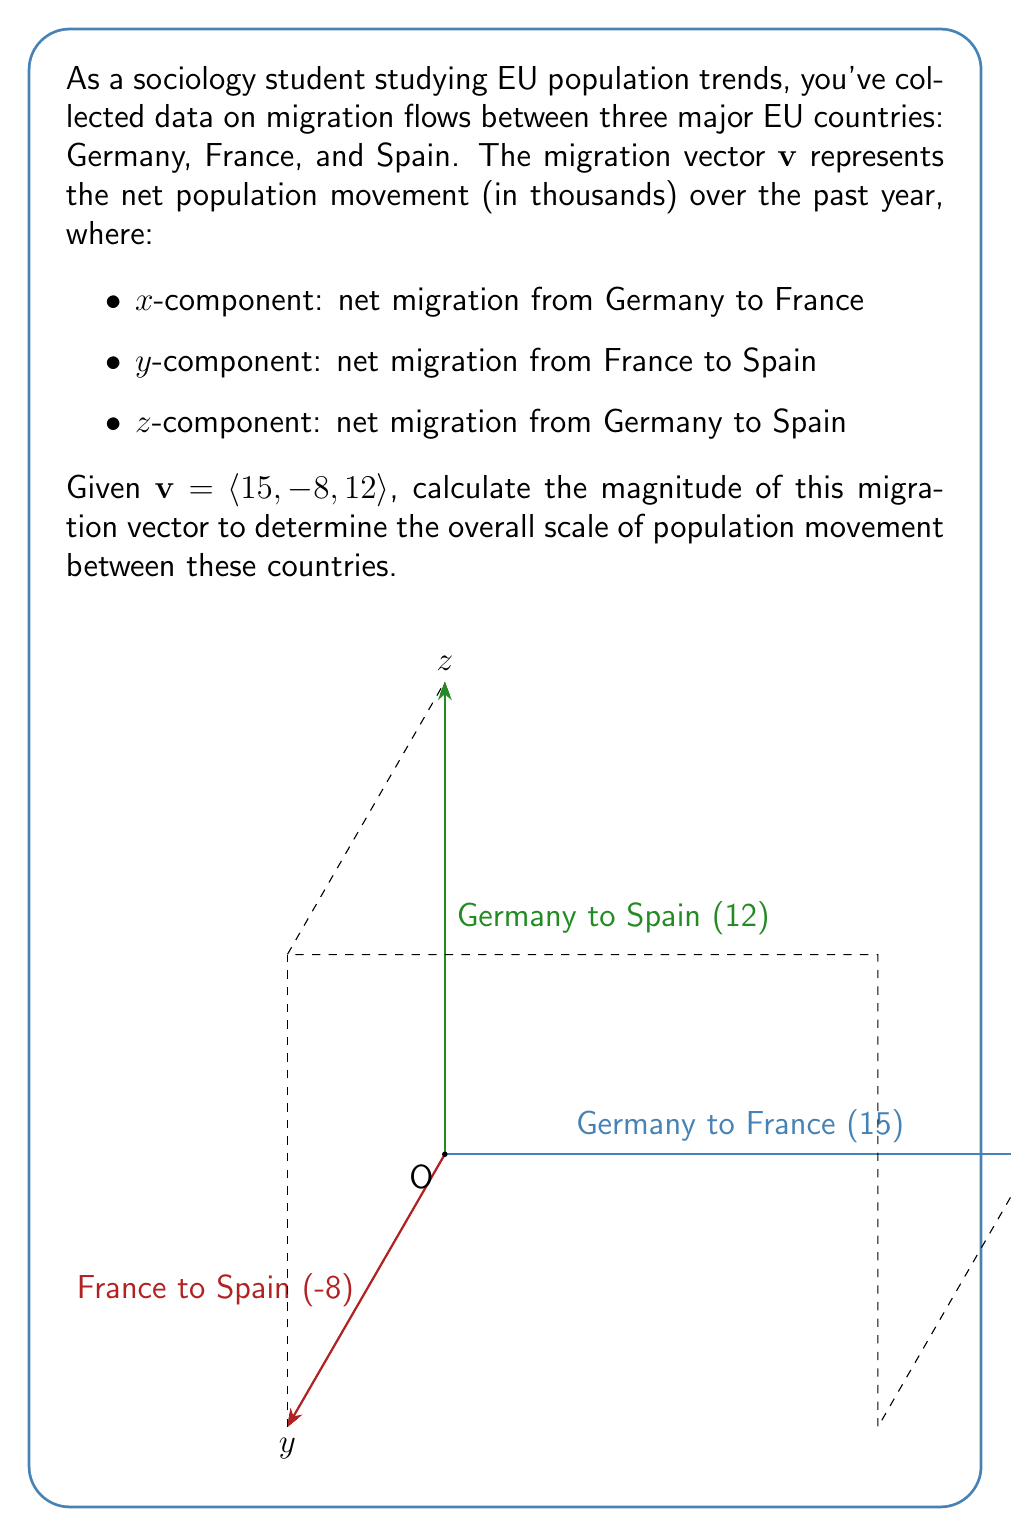Can you solve this math problem? To find the magnitude of the vector $\mathbf{v} = \langle 15, -8, 12 \rangle$, we need to use the formula for the magnitude of a 3D vector:

$$\|\mathbf{v}\| = \sqrt{x^2 + y^2 + z^2}$$

Where $x$, $y$, and $z$ are the components of the vector.

Let's substitute the values:

$$\|\mathbf{v}\| = \sqrt{15^2 + (-8)^2 + 12^2}$$

Now, let's calculate each term:
1. $15^2 = 225$
2. $(-8)^2 = 64$
3. $12^2 = 144$

Substituting these values:

$$\|\mathbf{v}\| = \sqrt{225 + 64 + 144}$$

Adding the terms under the square root:

$$\|\mathbf{v}\| = \sqrt{433}$$

The square root of 433 is approximately 20.81.

Since the vector components represent thousands of people, the magnitude also represents thousands.
Answer: $\|\mathbf{v}\| \approx 20.81$ thousand people 